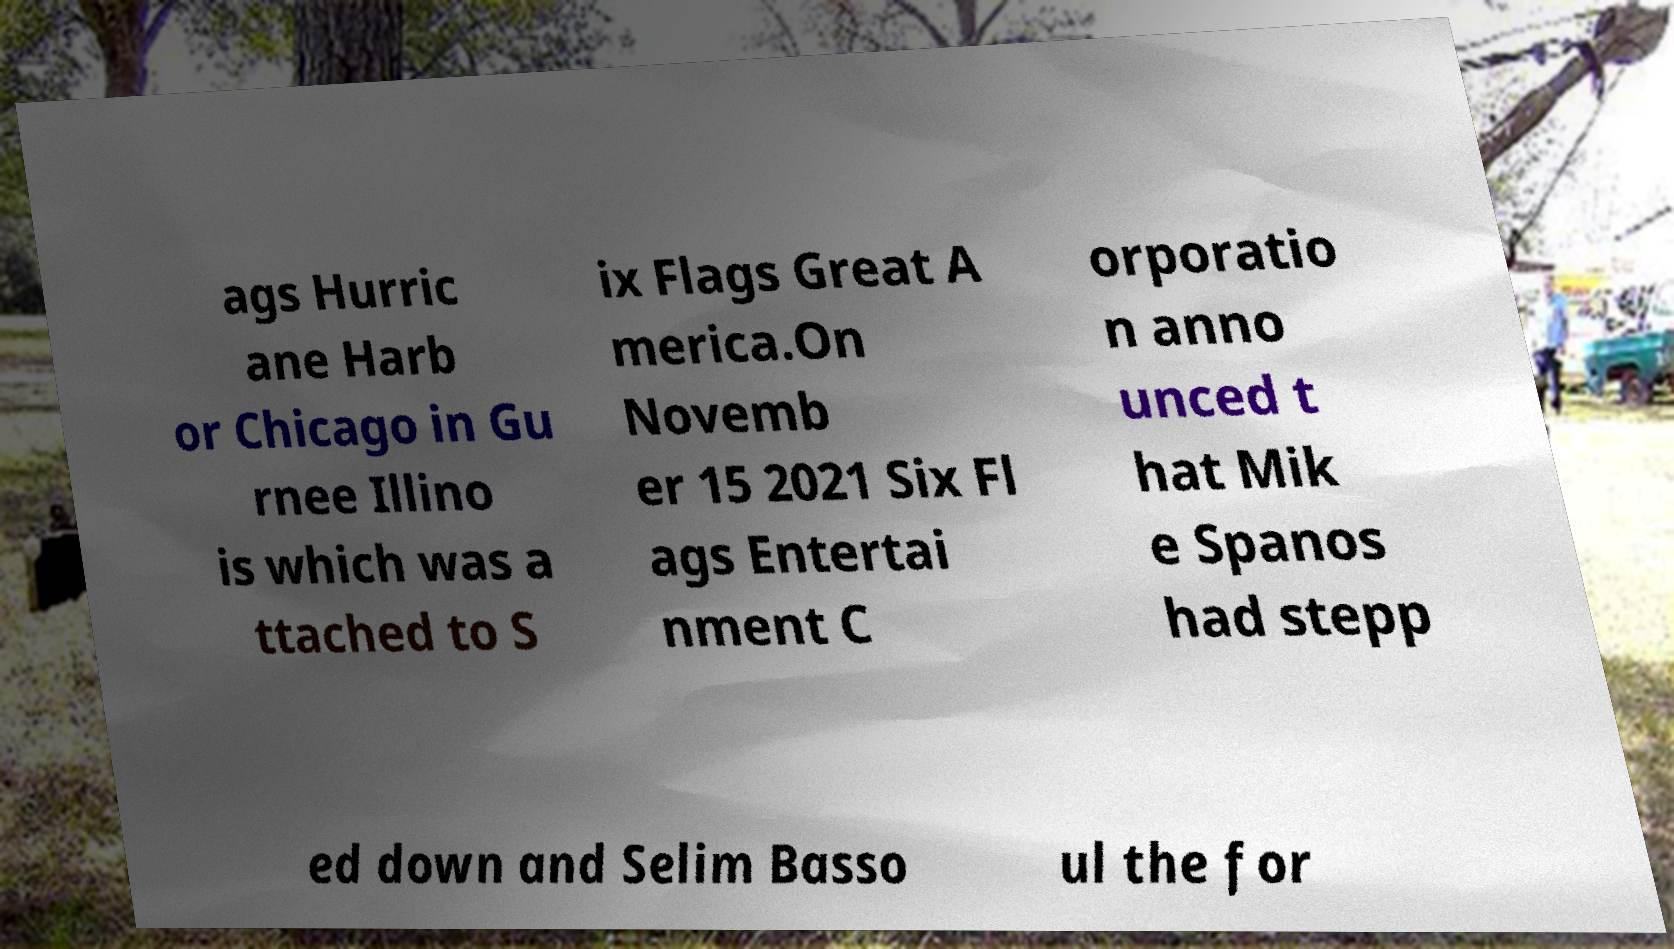Could you extract and type out the text from this image? ags Hurric ane Harb or Chicago in Gu rnee Illino is which was a ttached to S ix Flags Great A merica.On Novemb er 15 2021 Six Fl ags Entertai nment C orporatio n anno unced t hat Mik e Spanos had stepp ed down and Selim Basso ul the for 